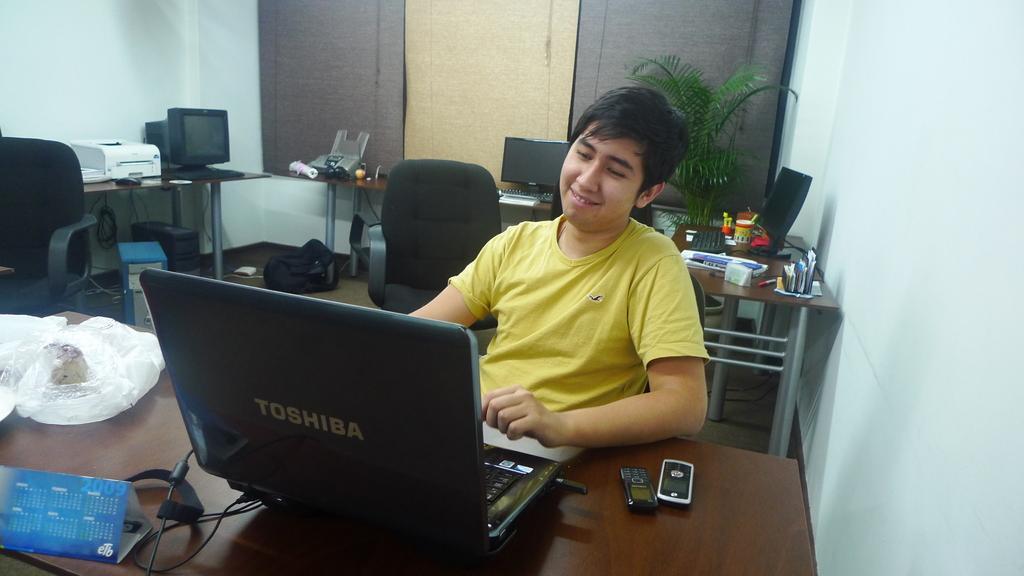How would you summarize this image in a sentence or two? In this image we can see a man sitting on the chair. On the table there is a laptop,mobile and a cover. At the background we can see a CPU,bag on the floor. On the table there are book holder,pen,cup and there is a wall. 